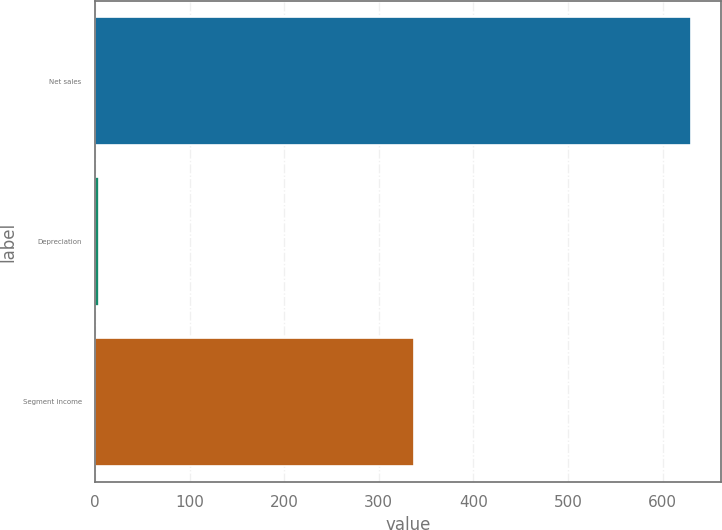<chart> <loc_0><loc_0><loc_500><loc_500><bar_chart><fcel>Net sales<fcel>Depreciation<fcel>Segment income<nl><fcel>630<fcel>4<fcel>337<nl></chart> 